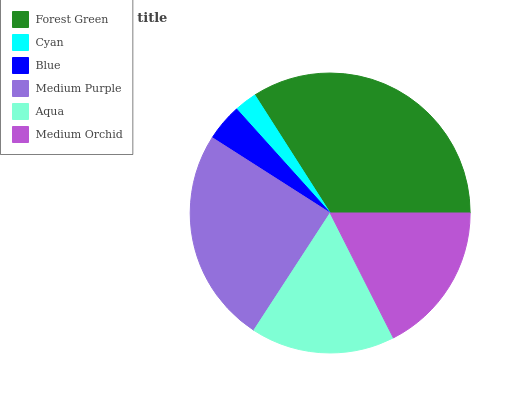Is Cyan the minimum?
Answer yes or no. Yes. Is Forest Green the maximum?
Answer yes or no. Yes. Is Blue the minimum?
Answer yes or no. No. Is Blue the maximum?
Answer yes or no. No. Is Blue greater than Cyan?
Answer yes or no. Yes. Is Cyan less than Blue?
Answer yes or no. Yes. Is Cyan greater than Blue?
Answer yes or no. No. Is Blue less than Cyan?
Answer yes or no. No. Is Medium Orchid the high median?
Answer yes or no. Yes. Is Aqua the low median?
Answer yes or no. Yes. Is Medium Purple the high median?
Answer yes or no. No. Is Blue the low median?
Answer yes or no. No. 